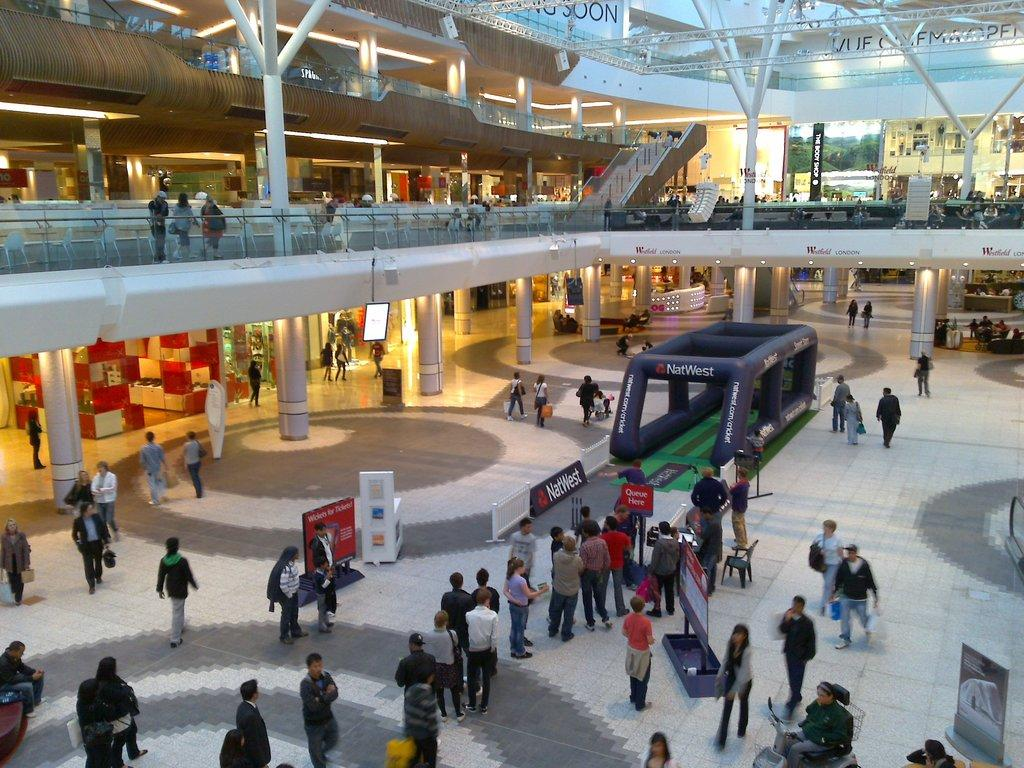What is happening in the image? There are persons standing in the image. What can be seen in the background of the image? There are stores around the persons. How many floors are visible in the image? There are two floors visible in the image. What is present on the upper floor? There are people and stores on the upper floor. What flavor of ice cream is being served on the tray in the image? There is no tray or ice cream present in the image. What value does the person standing on the upper floor place on the item they are holding? It is impossible to determine the value the person places on the item they are holding, as the image does not provide any information about the item or the person's thoughts or feelings. 